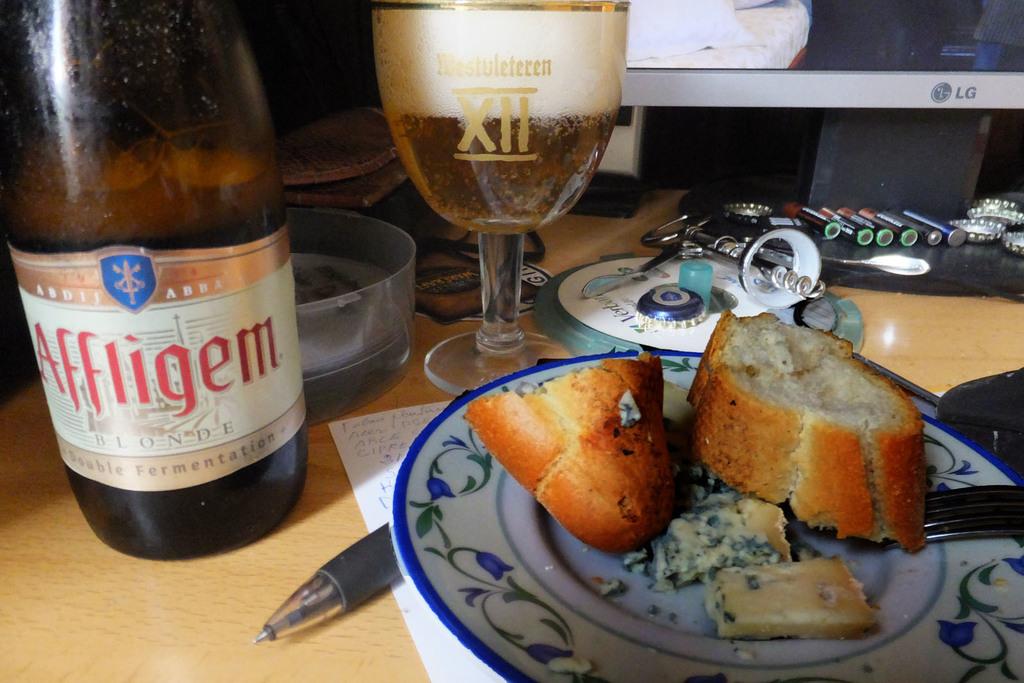Which romal numerals are those?
Offer a very short reply. Xii. 